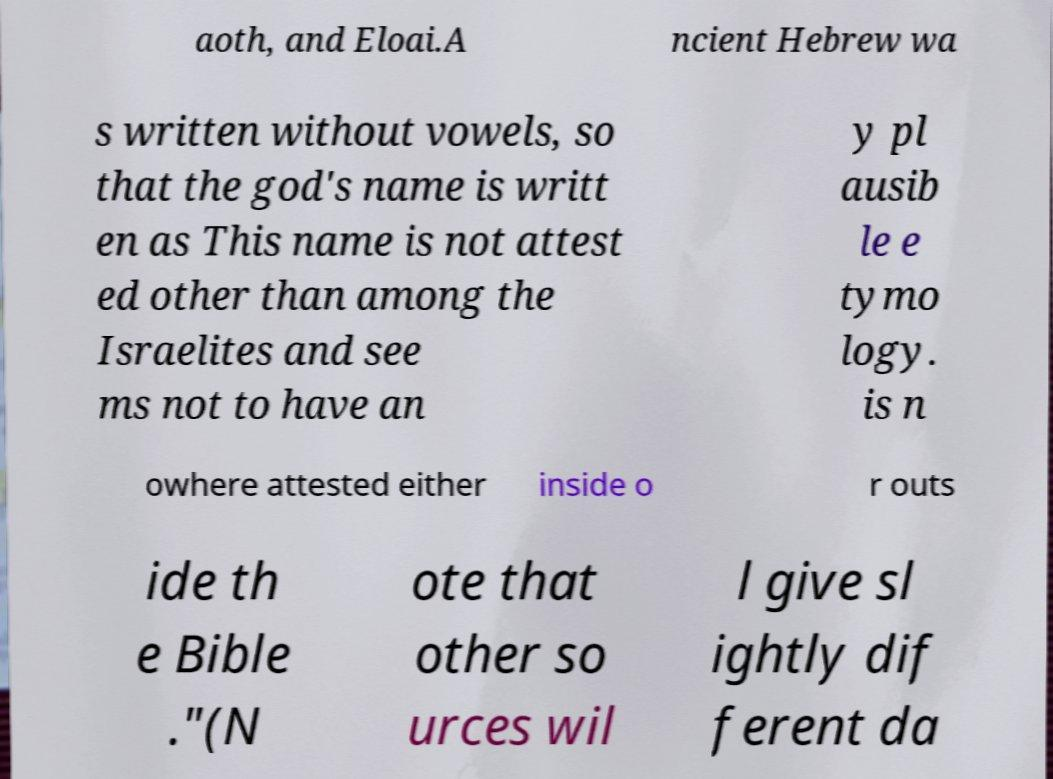For documentation purposes, I need the text within this image transcribed. Could you provide that? aoth, and Eloai.A ncient Hebrew wa s written without vowels, so that the god's name is writt en as This name is not attest ed other than among the Israelites and see ms not to have an y pl ausib le e tymo logy. is n owhere attested either inside o r outs ide th e Bible ."(N ote that other so urces wil l give sl ightly dif ferent da 